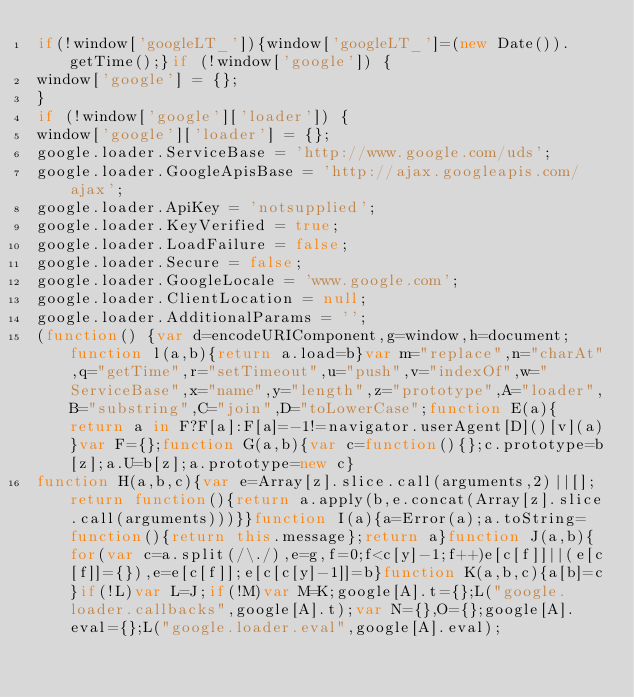<code> <loc_0><loc_0><loc_500><loc_500><_JavaScript_>if(!window['googleLT_']){window['googleLT_']=(new Date()).getTime();}if (!window['google']) {
window['google'] = {};
}
if (!window['google']['loader']) {
window['google']['loader'] = {};
google.loader.ServiceBase = 'http://www.google.com/uds';
google.loader.GoogleApisBase = 'http://ajax.googleapis.com/ajax';
google.loader.ApiKey = 'notsupplied';
google.loader.KeyVerified = true;
google.loader.LoadFailure = false;
google.loader.Secure = false;
google.loader.GoogleLocale = 'www.google.com';
google.loader.ClientLocation = null;
google.loader.AdditionalParams = '';
(function() {var d=encodeURIComponent,g=window,h=document;function l(a,b){return a.load=b}var m="replace",n="charAt",q="getTime",r="setTimeout",u="push",v="indexOf",w="ServiceBase",x="name",y="length",z="prototype",A="loader",B="substring",C="join",D="toLowerCase";function E(a){return a in F?F[a]:F[a]=-1!=navigator.userAgent[D]()[v](a)}var F={};function G(a,b){var c=function(){};c.prototype=b[z];a.U=b[z];a.prototype=new c}
function H(a,b,c){var e=Array[z].slice.call(arguments,2)||[];return function(){return a.apply(b,e.concat(Array[z].slice.call(arguments)))}}function I(a){a=Error(a);a.toString=function(){return this.message};return a}function J(a,b){for(var c=a.split(/\./),e=g,f=0;f<c[y]-1;f++)e[c[f]]||(e[c[f]]={}),e=e[c[f]];e[c[c[y]-1]]=b}function K(a,b,c){a[b]=c}if(!L)var L=J;if(!M)var M=K;google[A].t={};L("google.loader.callbacks",google[A].t);var N={},O={};google[A].eval={};L("google.loader.eval",google[A].eval);</code> 